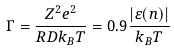Convert formula to latex. <formula><loc_0><loc_0><loc_500><loc_500>\Gamma = \frac { Z ^ { 2 } e ^ { 2 } } { R D k _ { B } T } = 0 . 9 \frac { | \varepsilon ( n ) | } { k _ { B } T }</formula> 